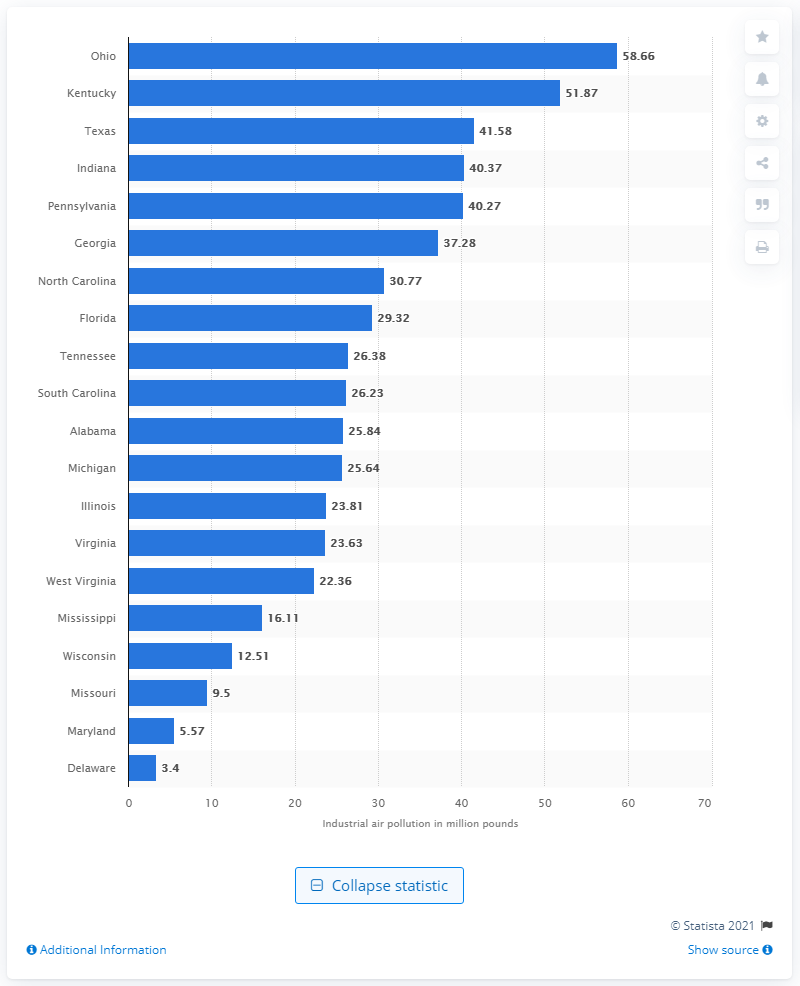Give some essential details in this illustration. In 2010, the industrial air pollution emissions in Ohio were 58.66. According to data collected in 2010, Ohio was the state that was most severely impacted by industrial air pollution. 